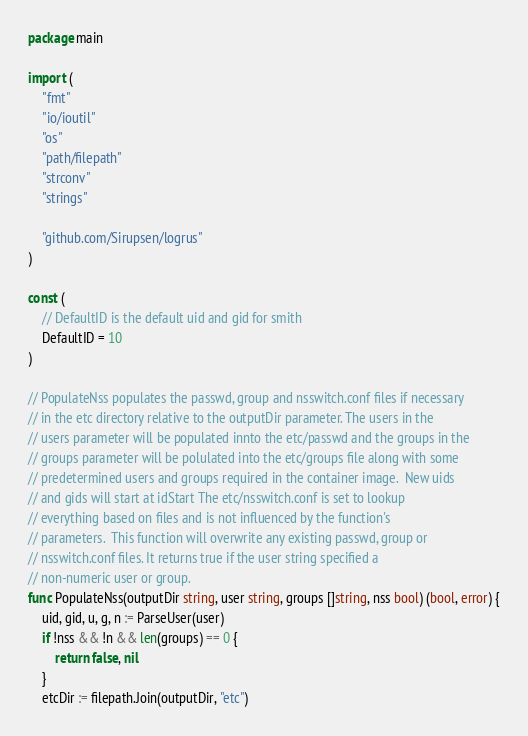<code> <loc_0><loc_0><loc_500><loc_500><_Go_>package main

import (
	"fmt"
	"io/ioutil"
	"os"
	"path/filepath"
	"strconv"
	"strings"

	"github.com/Sirupsen/logrus"
)

const (
	// DefaultID is the default uid and gid for smith
	DefaultID = 10
)

// PopulateNss populates the passwd, group and nsswitch.conf files if necessary
// in the etc directory relative to the outputDir parameter. The users in the
// users parameter will be populated innto the etc/passwd and the groups in the
// groups parameter will be polulated into the etc/groups file along with some
// predetermined users and groups required in the container image.  New uids
// and gids will start at idStart The etc/nsswitch.conf is set to lookup
// everything based on files and is not influenced by the function's
// parameters.  This function will overwrite any existing passwd, group or
// nsswitch.conf files. It returns true if the user string specified a
// non-numeric user or group.
func PopulateNss(outputDir string, user string, groups []string, nss bool) (bool, error) {
	uid, gid, u, g, n := ParseUser(user)
	if !nss && !n && len(groups) == 0 {
		return false, nil
	}
	etcDir := filepath.Join(outputDir, "etc")</code> 